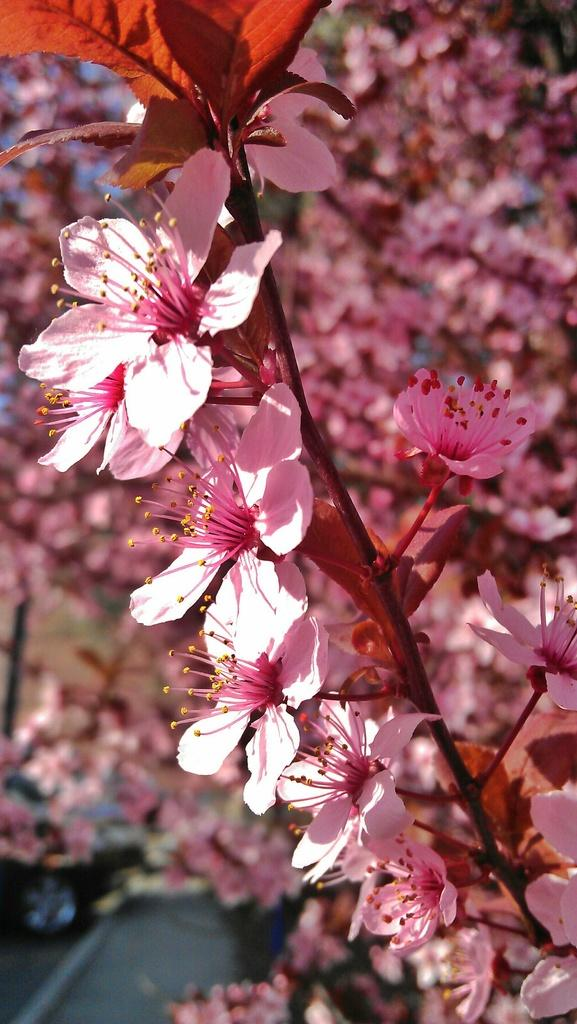What is the main subject of the image? The main subject of the image is a bunch of flowers. Can you describe any specific features or characteristics of the flowers? Unfortunately, the provided facts do not give any specific details about the flowers. What is the blur at the bottom of the image? The facts only mention the presence of a blur at the bottom of the image, but do not provide any further details about it. What type of current can be seen flowing through the pig's pie in the image? There is no pig or pie present in the image; it features a bunch of flowers and a blur at the bottom. 